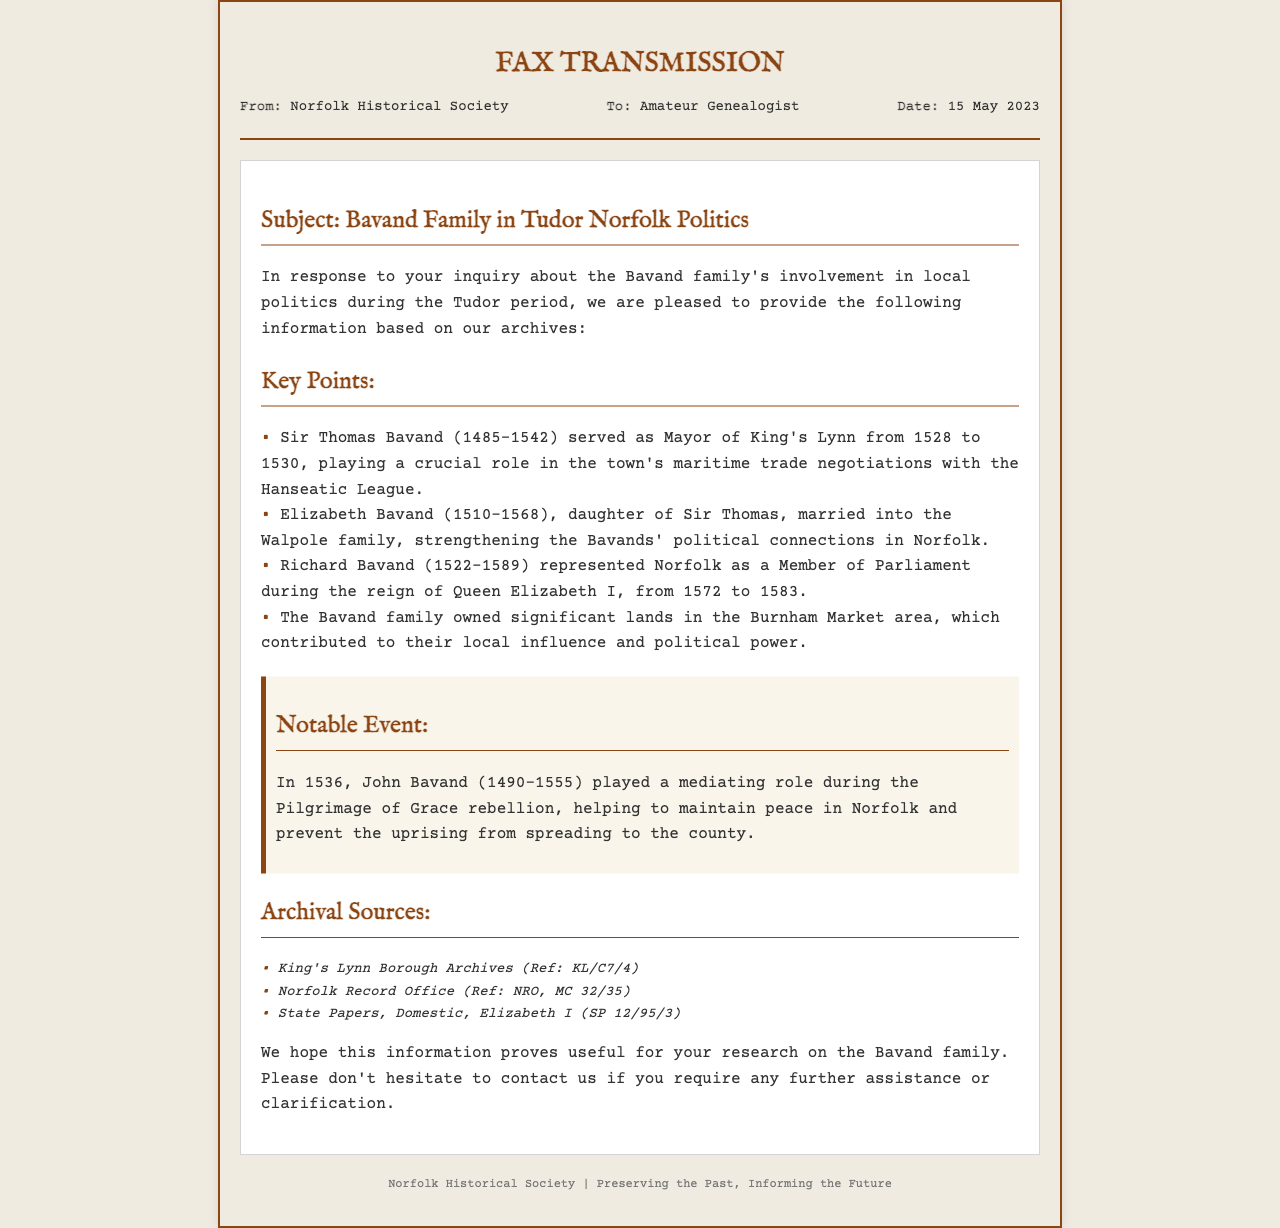What position did Sir Thomas Bavand hold? The document states that Sir Thomas Bavand served as Mayor of King's Lynn from 1528 to 1530.
Answer: Mayor of King's Lynn In what year did Richard Bavand serve as a Member of Parliament? The document indicates Richard Bavand represented Norfolk as a Member of Parliament during the reign of Queen Elizabeth I, from 1572 to 1583.
Answer: 1572 to 1583 Who did Elizabeth Bavand marry? According to the document, Elizabeth Bavand married into the Walpole family.
Answer: Walpole family What was the notable event involving John Bavand in 1536? The document mentions that John Bavand played a mediating role during the Pilgrimage of Grace rebellion in 1536.
Answer: Mediating role during the Pilgrimage of Grace rebellion What was the primary focus of Sir Thomas Bavand's political role? The document states that Sir Thomas Bavand played a crucial role in the town's maritime trade negotiations with the Hanseatic League.
Answer: Maritime trade negotiations How significant were the Bavands' lands to their political influence? The document specifies that the Bavand family owned significant lands in the Burnham Market area, contributing to their local influence and political power.
Answer: Significant lands in Burnham Market What type of document is this? The content and structure denote it as a fax transmission from a historical society.
Answer: Fax transmission What organization sent the fax? The document identifies the sender as the Norfolk Historical Society.
Answer: Norfolk Historical Society 